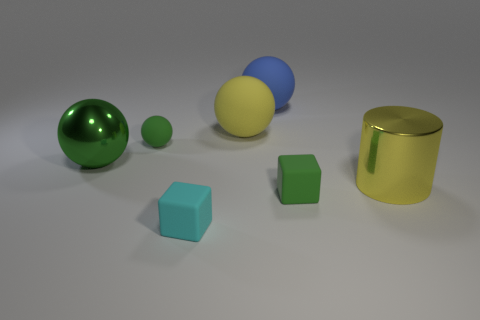What is the shape of the big matte object that is the same color as the shiny cylinder?
Your answer should be compact. Sphere. What is the color of the large metal sphere?
Ensure brevity in your answer.  Green. How many objects are either tiny balls or big yellow matte objects?
Your response must be concise. 2. Is there any other thing that is made of the same material as the blue object?
Make the answer very short. Yes. Is the number of tiny matte things that are in front of the yellow cylinder less than the number of small matte spheres?
Provide a succinct answer. No. Is the number of big spheres on the left side of the small cyan block greater than the number of green spheres in front of the yellow cylinder?
Ensure brevity in your answer.  Yes. Are there any other things that are the same color as the cylinder?
Ensure brevity in your answer.  Yes. There is a green ball that is behind the green metal ball; what is its material?
Offer a very short reply. Rubber. Do the blue rubber object and the yellow matte thing have the same size?
Ensure brevity in your answer.  Yes. What number of other objects are there of the same size as the yellow sphere?
Keep it short and to the point. 3. 